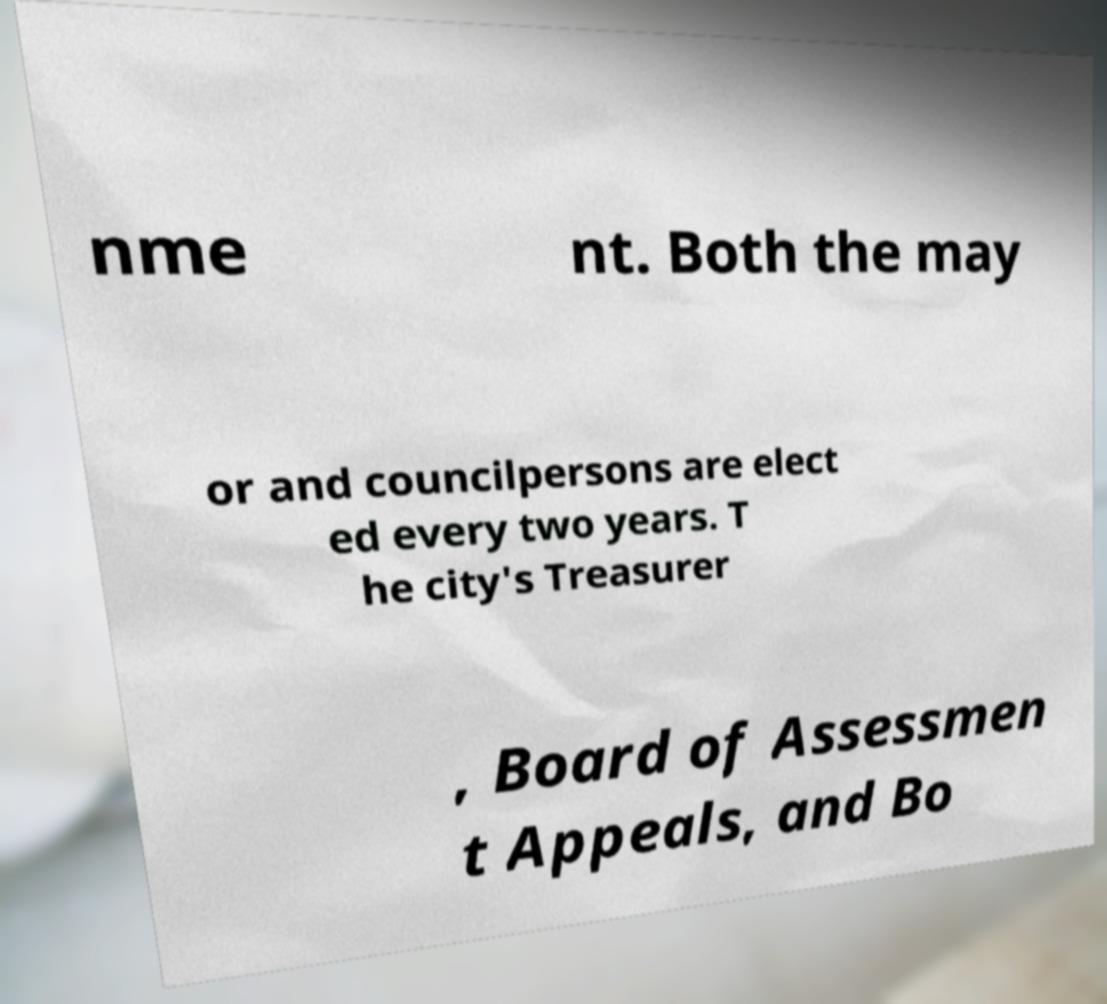There's text embedded in this image that I need extracted. Can you transcribe it verbatim? nme nt. Both the may or and councilpersons are elect ed every two years. T he city's Treasurer , Board of Assessmen t Appeals, and Bo 